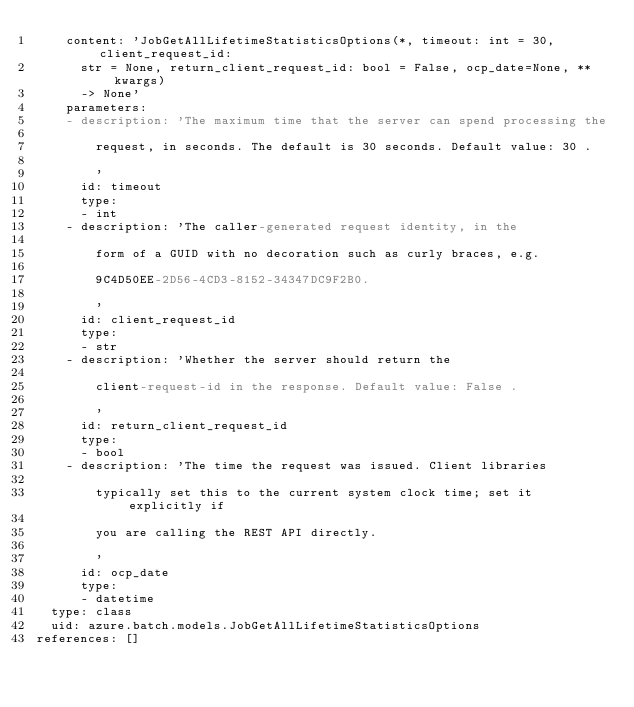<code> <loc_0><loc_0><loc_500><loc_500><_YAML_>    content: 'JobGetAllLifetimeStatisticsOptions(*, timeout: int = 30, client_request_id:
      str = None, return_client_request_id: bool = False, ocp_date=None, **kwargs)
      -> None'
    parameters:
    - description: 'The maximum time that the server can spend processing the

        request, in seconds. The default is 30 seconds. Default value: 30 .

        '
      id: timeout
      type:
      - int
    - description: 'The caller-generated request identity, in the

        form of a GUID with no decoration such as curly braces, e.g.

        9C4D50EE-2D56-4CD3-8152-34347DC9F2B0.

        '
      id: client_request_id
      type:
      - str
    - description: 'Whether the server should return the

        client-request-id in the response. Default value: False .

        '
      id: return_client_request_id
      type:
      - bool
    - description: 'The time the request was issued. Client libraries

        typically set this to the current system clock time; set it explicitly if

        you are calling the REST API directly.

        '
      id: ocp_date
      type:
      - datetime
  type: class
  uid: azure.batch.models.JobGetAllLifetimeStatisticsOptions
references: []
</code> 